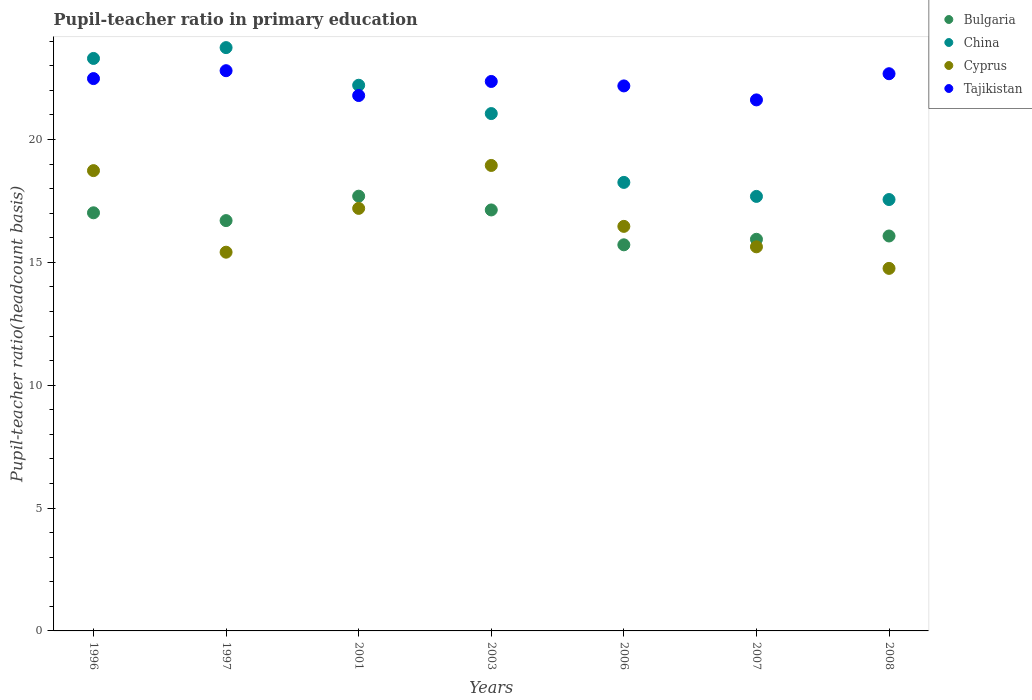Is the number of dotlines equal to the number of legend labels?
Your response must be concise. Yes. What is the pupil-teacher ratio in primary education in Bulgaria in 1996?
Keep it short and to the point. 17.01. Across all years, what is the maximum pupil-teacher ratio in primary education in Cyprus?
Provide a succinct answer. 18.94. Across all years, what is the minimum pupil-teacher ratio in primary education in Bulgaria?
Your answer should be compact. 15.71. In which year was the pupil-teacher ratio in primary education in Bulgaria minimum?
Your answer should be very brief. 2006. What is the total pupil-teacher ratio in primary education in Tajikistan in the graph?
Your response must be concise. 155.88. What is the difference between the pupil-teacher ratio in primary education in Tajikistan in 1996 and that in 2001?
Offer a terse response. 0.69. What is the difference between the pupil-teacher ratio in primary education in China in 2006 and the pupil-teacher ratio in primary education in Cyprus in 2008?
Give a very brief answer. 3.5. What is the average pupil-teacher ratio in primary education in China per year?
Ensure brevity in your answer.  20.54. In the year 2006, what is the difference between the pupil-teacher ratio in primary education in Cyprus and pupil-teacher ratio in primary education in China?
Offer a terse response. -1.79. What is the ratio of the pupil-teacher ratio in primary education in China in 1996 to that in 2003?
Provide a succinct answer. 1.11. Is the pupil-teacher ratio in primary education in China in 2007 less than that in 2008?
Offer a very short reply. No. Is the difference between the pupil-teacher ratio in primary education in Cyprus in 2006 and 2007 greater than the difference between the pupil-teacher ratio in primary education in China in 2006 and 2007?
Provide a short and direct response. Yes. What is the difference between the highest and the second highest pupil-teacher ratio in primary education in China?
Make the answer very short. 0.44. What is the difference between the highest and the lowest pupil-teacher ratio in primary education in Bulgaria?
Give a very brief answer. 1.98. In how many years, is the pupil-teacher ratio in primary education in Bulgaria greater than the average pupil-teacher ratio in primary education in Bulgaria taken over all years?
Provide a short and direct response. 4. Is the sum of the pupil-teacher ratio in primary education in Cyprus in 1996 and 2008 greater than the maximum pupil-teacher ratio in primary education in Tajikistan across all years?
Keep it short and to the point. Yes. Is it the case that in every year, the sum of the pupil-teacher ratio in primary education in Bulgaria and pupil-teacher ratio in primary education in Cyprus  is greater than the sum of pupil-teacher ratio in primary education in China and pupil-teacher ratio in primary education in Tajikistan?
Provide a succinct answer. No. Does the pupil-teacher ratio in primary education in Bulgaria monotonically increase over the years?
Offer a very short reply. No. Is the pupil-teacher ratio in primary education in Bulgaria strictly greater than the pupil-teacher ratio in primary education in China over the years?
Keep it short and to the point. No. Is the pupil-teacher ratio in primary education in China strictly less than the pupil-teacher ratio in primary education in Tajikistan over the years?
Provide a short and direct response. No. What is the difference between two consecutive major ticks on the Y-axis?
Offer a terse response. 5. Does the graph contain grids?
Your answer should be very brief. No. Where does the legend appear in the graph?
Your answer should be compact. Top right. How many legend labels are there?
Offer a terse response. 4. How are the legend labels stacked?
Your answer should be compact. Vertical. What is the title of the graph?
Give a very brief answer. Pupil-teacher ratio in primary education. What is the label or title of the X-axis?
Offer a very short reply. Years. What is the label or title of the Y-axis?
Make the answer very short. Pupil-teacher ratio(headcount basis). What is the Pupil-teacher ratio(headcount basis) in Bulgaria in 1996?
Your answer should be very brief. 17.01. What is the Pupil-teacher ratio(headcount basis) in China in 1996?
Your answer should be very brief. 23.3. What is the Pupil-teacher ratio(headcount basis) of Cyprus in 1996?
Your answer should be very brief. 18.73. What is the Pupil-teacher ratio(headcount basis) of Tajikistan in 1996?
Your response must be concise. 22.48. What is the Pupil-teacher ratio(headcount basis) in Bulgaria in 1997?
Provide a succinct answer. 16.7. What is the Pupil-teacher ratio(headcount basis) of China in 1997?
Offer a terse response. 23.74. What is the Pupil-teacher ratio(headcount basis) of Cyprus in 1997?
Your response must be concise. 15.41. What is the Pupil-teacher ratio(headcount basis) in Tajikistan in 1997?
Your response must be concise. 22.8. What is the Pupil-teacher ratio(headcount basis) of Bulgaria in 2001?
Your answer should be very brief. 17.69. What is the Pupil-teacher ratio(headcount basis) in China in 2001?
Your answer should be compact. 22.21. What is the Pupil-teacher ratio(headcount basis) of Cyprus in 2001?
Your answer should be compact. 17.19. What is the Pupil-teacher ratio(headcount basis) in Tajikistan in 2001?
Your answer should be compact. 21.79. What is the Pupil-teacher ratio(headcount basis) in Bulgaria in 2003?
Make the answer very short. 17.13. What is the Pupil-teacher ratio(headcount basis) of China in 2003?
Keep it short and to the point. 21.05. What is the Pupil-teacher ratio(headcount basis) in Cyprus in 2003?
Give a very brief answer. 18.94. What is the Pupil-teacher ratio(headcount basis) in Tajikistan in 2003?
Give a very brief answer. 22.36. What is the Pupil-teacher ratio(headcount basis) of Bulgaria in 2006?
Provide a short and direct response. 15.71. What is the Pupil-teacher ratio(headcount basis) in China in 2006?
Offer a very short reply. 18.25. What is the Pupil-teacher ratio(headcount basis) in Cyprus in 2006?
Ensure brevity in your answer.  16.46. What is the Pupil-teacher ratio(headcount basis) in Tajikistan in 2006?
Provide a short and direct response. 22.18. What is the Pupil-teacher ratio(headcount basis) in Bulgaria in 2007?
Make the answer very short. 15.94. What is the Pupil-teacher ratio(headcount basis) in China in 2007?
Your answer should be compact. 17.68. What is the Pupil-teacher ratio(headcount basis) of Cyprus in 2007?
Keep it short and to the point. 15.63. What is the Pupil-teacher ratio(headcount basis) in Tajikistan in 2007?
Offer a terse response. 21.61. What is the Pupil-teacher ratio(headcount basis) in Bulgaria in 2008?
Provide a succinct answer. 16.07. What is the Pupil-teacher ratio(headcount basis) in China in 2008?
Give a very brief answer. 17.55. What is the Pupil-teacher ratio(headcount basis) of Cyprus in 2008?
Your response must be concise. 14.75. What is the Pupil-teacher ratio(headcount basis) in Tajikistan in 2008?
Offer a terse response. 22.67. Across all years, what is the maximum Pupil-teacher ratio(headcount basis) in Bulgaria?
Your response must be concise. 17.69. Across all years, what is the maximum Pupil-teacher ratio(headcount basis) of China?
Offer a terse response. 23.74. Across all years, what is the maximum Pupil-teacher ratio(headcount basis) of Cyprus?
Provide a succinct answer. 18.94. Across all years, what is the maximum Pupil-teacher ratio(headcount basis) in Tajikistan?
Your answer should be very brief. 22.8. Across all years, what is the minimum Pupil-teacher ratio(headcount basis) in Bulgaria?
Ensure brevity in your answer.  15.71. Across all years, what is the minimum Pupil-teacher ratio(headcount basis) of China?
Make the answer very short. 17.55. Across all years, what is the minimum Pupil-teacher ratio(headcount basis) of Cyprus?
Ensure brevity in your answer.  14.75. Across all years, what is the minimum Pupil-teacher ratio(headcount basis) in Tajikistan?
Ensure brevity in your answer.  21.61. What is the total Pupil-teacher ratio(headcount basis) in Bulgaria in the graph?
Provide a succinct answer. 116.25. What is the total Pupil-teacher ratio(headcount basis) of China in the graph?
Offer a terse response. 143.78. What is the total Pupil-teacher ratio(headcount basis) in Cyprus in the graph?
Ensure brevity in your answer.  117.13. What is the total Pupil-teacher ratio(headcount basis) of Tajikistan in the graph?
Keep it short and to the point. 155.88. What is the difference between the Pupil-teacher ratio(headcount basis) of Bulgaria in 1996 and that in 1997?
Make the answer very short. 0.32. What is the difference between the Pupil-teacher ratio(headcount basis) in China in 1996 and that in 1997?
Offer a terse response. -0.44. What is the difference between the Pupil-teacher ratio(headcount basis) in Cyprus in 1996 and that in 1997?
Give a very brief answer. 3.32. What is the difference between the Pupil-teacher ratio(headcount basis) in Tajikistan in 1996 and that in 1997?
Your response must be concise. -0.32. What is the difference between the Pupil-teacher ratio(headcount basis) of Bulgaria in 1996 and that in 2001?
Your answer should be very brief. -0.68. What is the difference between the Pupil-teacher ratio(headcount basis) in China in 1996 and that in 2001?
Make the answer very short. 1.09. What is the difference between the Pupil-teacher ratio(headcount basis) of Cyprus in 1996 and that in 2001?
Offer a very short reply. 1.54. What is the difference between the Pupil-teacher ratio(headcount basis) in Tajikistan in 1996 and that in 2001?
Offer a terse response. 0.69. What is the difference between the Pupil-teacher ratio(headcount basis) in Bulgaria in 1996 and that in 2003?
Give a very brief answer. -0.12. What is the difference between the Pupil-teacher ratio(headcount basis) in China in 1996 and that in 2003?
Your response must be concise. 2.24. What is the difference between the Pupil-teacher ratio(headcount basis) in Cyprus in 1996 and that in 2003?
Provide a succinct answer. -0.21. What is the difference between the Pupil-teacher ratio(headcount basis) in Tajikistan in 1996 and that in 2003?
Keep it short and to the point. 0.12. What is the difference between the Pupil-teacher ratio(headcount basis) in Bulgaria in 1996 and that in 2006?
Provide a short and direct response. 1.3. What is the difference between the Pupil-teacher ratio(headcount basis) in China in 1996 and that in 2006?
Offer a very short reply. 5.04. What is the difference between the Pupil-teacher ratio(headcount basis) of Cyprus in 1996 and that in 2006?
Keep it short and to the point. 2.27. What is the difference between the Pupil-teacher ratio(headcount basis) of Tajikistan in 1996 and that in 2006?
Give a very brief answer. 0.3. What is the difference between the Pupil-teacher ratio(headcount basis) of Bulgaria in 1996 and that in 2007?
Keep it short and to the point. 1.08. What is the difference between the Pupil-teacher ratio(headcount basis) of China in 1996 and that in 2007?
Offer a terse response. 5.61. What is the difference between the Pupil-teacher ratio(headcount basis) of Cyprus in 1996 and that in 2007?
Provide a short and direct response. 3.1. What is the difference between the Pupil-teacher ratio(headcount basis) in Tajikistan in 1996 and that in 2007?
Keep it short and to the point. 0.87. What is the difference between the Pupil-teacher ratio(headcount basis) in Bulgaria in 1996 and that in 2008?
Provide a short and direct response. 0.94. What is the difference between the Pupil-teacher ratio(headcount basis) of China in 1996 and that in 2008?
Your response must be concise. 5.74. What is the difference between the Pupil-teacher ratio(headcount basis) of Cyprus in 1996 and that in 2008?
Offer a terse response. 3.98. What is the difference between the Pupil-teacher ratio(headcount basis) in Tajikistan in 1996 and that in 2008?
Offer a terse response. -0.2. What is the difference between the Pupil-teacher ratio(headcount basis) of Bulgaria in 1997 and that in 2001?
Offer a terse response. -0.99. What is the difference between the Pupil-teacher ratio(headcount basis) of China in 1997 and that in 2001?
Offer a terse response. 1.53. What is the difference between the Pupil-teacher ratio(headcount basis) in Cyprus in 1997 and that in 2001?
Your answer should be compact. -1.78. What is the difference between the Pupil-teacher ratio(headcount basis) of Tajikistan in 1997 and that in 2001?
Make the answer very short. 1.01. What is the difference between the Pupil-teacher ratio(headcount basis) of Bulgaria in 1997 and that in 2003?
Your answer should be very brief. -0.43. What is the difference between the Pupil-teacher ratio(headcount basis) of China in 1997 and that in 2003?
Ensure brevity in your answer.  2.68. What is the difference between the Pupil-teacher ratio(headcount basis) of Cyprus in 1997 and that in 2003?
Offer a terse response. -3.53. What is the difference between the Pupil-teacher ratio(headcount basis) in Tajikistan in 1997 and that in 2003?
Your answer should be very brief. 0.44. What is the difference between the Pupil-teacher ratio(headcount basis) of Bulgaria in 1997 and that in 2006?
Give a very brief answer. 0.99. What is the difference between the Pupil-teacher ratio(headcount basis) in China in 1997 and that in 2006?
Your response must be concise. 5.49. What is the difference between the Pupil-teacher ratio(headcount basis) of Cyprus in 1997 and that in 2006?
Give a very brief answer. -1.05. What is the difference between the Pupil-teacher ratio(headcount basis) of Tajikistan in 1997 and that in 2006?
Provide a short and direct response. 0.62. What is the difference between the Pupil-teacher ratio(headcount basis) of Bulgaria in 1997 and that in 2007?
Offer a very short reply. 0.76. What is the difference between the Pupil-teacher ratio(headcount basis) in China in 1997 and that in 2007?
Your answer should be very brief. 6.05. What is the difference between the Pupil-teacher ratio(headcount basis) of Cyprus in 1997 and that in 2007?
Ensure brevity in your answer.  -0.22. What is the difference between the Pupil-teacher ratio(headcount basis) of Tajikistan in 1997 and that in 2007?
Your response must be concise. 1.19. What is the difference between the Pupil-teacher ratio(headcount basis) of Bulgaria in 1997 and that in 2008?
Ensure brevity in your answer.  0.63. What is the difference between the Pupil-teacher ratio(headcount basis) in China in 1997 and that in 2008?
Offer a very short reply. 6.18. What is the difference between the Pupil-teacher ratio(headcount basis) in Cyprus in 1997 and that in 2008?
Your answer should be compact. 0.66. What is the difference between the Pupil-teacher ratio(headcount basis) in Tajikistan in 1997 and that in 2008?
Offer a terse response. 0.12. What is the difference between the Pupil-teacher ratio(headcount basis) of Bulgaria in 2001 and that in 2003?
Your answer should be compact. 0.56. What is the difference between the Pupil-teacher ratio(headcount basis) in China in 2001 and that in 2003?
Give a very brief answer. 1.15. What is the difference between the Pupil-teacher ratio(headcount basis) of Cyprus in 2001 and that in 2003?
Give a very brief answer. -1.75. What is the difference between the Pupil-teacher ratio(headcount basis) of Tajikistan in 2001 and that in 2003?
Your answer should be very brief. -0.57. What is the difference between the Pupil-teacher ratio(headcount basis) in Bulgaria in 2001 and that in 2006?
Provide a short and direct response. 1.98. What is the difference between the Pupil-teacher ratio(headcount basis) of China in 2001 and that in 2006?
Offer a very short reply. 3.95. What is the difference between the Pupil-teacher ratio(headcount basis) of Cyprus in 2001 and that in 2006?
Your answer should be compact. 0.73. What is the difference between the Pupil-teacher ratio(headcount basis) of Tajikistan in 2001 and that in 2006?
Provide a succinct answer. -0.39. What is the difference between the Pupil-teacher ratio(headcount basis) of Bulgaria in 2001 and that in 2007?
Ensure brevity in your answer.  1.75. What is the difference between the Pupil-teacher ratio(headcount basis) in China in 2001 and that in 2007?
Provide a short and direct response. 4.52. What is the difference between the Pupil-teacher ratio(headcount basis) of Cyprus in 2001 and that in 2007?
Your answer should be compact. 1.56. What is the difference between the Pupil-teacher ratio(headcount basis) of Tajikistan in 2001 and that in 2007?
Offer a very short reply. 0.18. What is the difference between the Pupil-teacher ratio(headcount basis) of Bulgaria in 2001 and that in 2008?
Your answer should be very brief. 1.62. What is the difference between the Pupil-teacher ratio(headcount basis) of China in 2001 and that in 2008?
Keep it short and to the point. 4.65. What is the difference between the Pupil-teacher ratio(headcount basis) in Cyprus in 2001 and that in 2008?
Keep it short and to the point. 2.44. What is the difference between the Pupil-teacher ratio(headcount basis) of Tajikistan in 2001 and that in 2008?
Make the answer very short. -0.89. What is the difference between the Pupil-teacher ratio(headcount basis) in Bulgaria in 2003 and that in 2006?
Your answer should be very brief. 1.42. What is the difference between the Pupil-teacher ratio(headcount basis) of China in 2003 and that in 2006?
Your answer should be compact. 2.8. What is the difference between the Pupil-teacher ratio(headcount basis) in Cyprus in 2003 and that in 2006?
Provide a succinct answer. 2.48. What is the difference between the Pupil-teacher ratio(headcount basis) of Tajikistan in 2003 and that in 2006?
Ensure brevity in your answer.  0.18. What is the difference between the Pupil-teacher ratio(headcount basis) of Bulgaria in 2003 and that in 2007?
Offer a very short reply. 1.19. What is the difference between the Pupil-teacher ratio(headcount basis) of China in 2003 and that in 2007?
Provide a succinct answer. 3.37. What is the difference between the Pupil-teacher ratio(headcount basis) of Cyprus in 2003 and that in 2007?
Ensure brevity in your answer.  3.31. What is the difference between the Pupil-teacher ratio(headcount basis) in Tajikistan in 2003 and that in 2007?
Provide a succinct answer. 0.75. What is the difference between the Pupil-teacher ratio(headcount basis) of Bulgaria in 2003 and that in 2008?
Provide a succinct answer. 1.06. What is the difference between the Pupil-teacher ratio(headcount basis) of China in 2003 and that in 2008?
Offer a terse response. 3.5. What is the difference between the Pupil-teacher ratio(headcount basis) in Cyprus in 2003 and that in 2008?
Offer a terse response. 4.19. What is the difference between the Pupil-teacher ratio(headcount basis) of Tajikistan in 2003 and that in 2008?
Your response must be concise. -0.31. What is the difference between the Pupil-teacher ratio(headcount basis) in Bulgaria in 2006 and that in 2007?
Your answer should be compact. -0.23. What is the difference between the Pupil-teacher ratio(headcount basis) in China in 2006 and that in 2007?
Offer a terse response. 0.57. What is the difference between the Pupil-teacher ratio(headcount basis) of Cyprus in 2006 and that in 2007?
Offer a very short reply. 0.83. What is the difference between the Pupil-teacher ratio(headcount basis) in Tajikistan in 2006 and that in 2007?
Give a very brief answer. 0.57. What is the difference between the Pupil-teacher ratio(headcount basis) in Bulgaria in 2006 and that in 2008?
Offer a terse response. -0.36. What is the difference between the Pupil-teacher ratio(headcount basis) in China in 2006 and that in 2008?
Your answer should be very brief. 0.7. What is the difference between the Pupil-teacher ratio(headcount basis) in Cyprus in 2006 and that in 2008?
Make the answer very short. 1.71. What is the difference between the Pupil-teacher ratio(headcount basis) in Tajikistan in 2006 and that in 2008?
Your answer should be compact. -0.5. What is the difference between the Pupil-teacher ratio(headcount basis) of Bulgaria in 2007 and that in 2008?
Your answer should be very brief. -0.13. What is the difference between the Pupil-teacher ratio(headcount basis) in China in 2007 and that in 2008?
Your answer should be compact. 0.13. What is the difference between the Pupil-teacher ratio(headcount basis) of Cyprus in 2007 and that in 2008?
Keep it short and to the point. 0.88. What is the difference between the Pupil-teacher ratio(headcount basis) of Tajikistan in 2007 and that in 2008?
Your answer should be compact. -1.06. What is the difference between the Pupil-teacher ratio(headcount basis) in Bulgaria in 1996 and the Pupil-teacher ratio(headcount basis) in China in 1997?
Offer a terse response. -6.72. What is the difference between the Pupil-teacher ratio(headcount basis) in Bulgaria in 1996 and the Pupil-teacher ratio(headcount basis) in Cyprus in 1997?
Give a very brief answer. 1.6. What is the difference between the Pupil-teacher ratio(headcount basis) in Bulgaria in 1996 and the Pupil-teacher ratio(headcount basis) in Tajikistan in 1997?
Your answer should be very brief. -5.78. What is the difference between the Pupil-teacher ratio(headcount basis) in China in 1996 and the Pupil-teacher ratio(headcount basis) in Cyprus in 1997?
Provide a succinct answer. 7.88. What is the difference between the Pupil-teacher ratio(headcount basis) in China in 1996 and the Pupil-teacher ratio(headcount basis) in Tajikistan in 1997?
Keep it short and to the point. 0.5. What is the difference between the Pupil-teacher ratio(headcount basis) of Cyprus in 1996 and the Pupil-teacher ratio(headcount basis) of Tajikistan in 1997?
Your answer should be compact. -4.07. What is the difference between the Pupil-teacher ratio(headcount basis) in Bulgaria in 1996 and the Pupil-teacher ratio(headcount basis) in China in 2001?
Provide a short and direct response. -5.19. What is the difference between the Pupil-teacher ratio(headcount basis) of Bulgaria in 1996 and the Pupil-teacher ratio(headcount basis) of Cyprus in 2001?
Provide a short and direct response. -0.18. What is the difference between the Pupil-teacher ratio(headcount basis) in Bulgaria in 1996 and the Pupil-teacher ratio(headcount basis) in Tajikistan in 2001?
Keep it short and to the point. -4.77. What is the difference between the Pupil-teacher ratio(headcount basis) in China in 1996 and the Pupil-teacher ratio(headcount basis) in Cyprus in 2001?
Your response must be concise. 6.1. What is the difference between the Pupil-teacher ratio(headcount basis) in China in 1996 and the Pupil-teacher ratio(headcount basis) in Tajikistan in 2001?
Ensure brevity in your answer.  1.51. What is the difference between the Pupil-teacher ratio(headcount basis) in Cyprus in 1996 and the Pupil-teacher ratio(headcount basis) in Tajikistan in 2001?
Your response must be concise. -3.06. What is the difference between the Pupil-teacher ratio(headcount basis) of Bulgaria in 1996 and the Pupil-teacher ratio(headcount basis) of China in 2003?
Ensure brevity in your answer.  -4.04. What is the difference between the Pupil-teacher ratio(headcount basis) in Bulgaria in 1996 and the Pupil-teacher ratio(headcount basis) in Cyprus in 2003?
Make the answer very short. -1.93. What is the difference between the Pupil-teacher ratio(headcount basis) of Bulgaria in 1996 and the Pupil-teacher ratio(headcount basis) of Tajikistan in 2003?
Give a very brief answer. -5.34. What is the difference between the Pupil-teacher ratio(headcount basis) of China in 1996 and the Pupil-teacher ratio(headcount basis) of Cyprus in 2003?
Offer a terse response. 4.35. What is the difference between the Pupil-teacher ratio(headcount basis) in China in 1996 and the Pupil-teacher ratio(headcount basis) in Tajikistan in 2003?
Give a very brief answer. 0.94. What is the difference between the Pupil-teacher ratio(headcount basis) in Cyprus in 1996 and the Pupil-teacher ratio(headcount basis) in Tajikistan in 2003?
Offer a terse response. -3.63. What is the difference between the Pupil-teacher ratio(headcount basis) of Bulgaria in 1996 and the Pupil-teacher ratio(headcount basis) of China in 2006?
Your answer should be very brief. -1.24. What is the difference between the Pupil-teacher ratio(headcount basis) of Bulgaria in 1996 and the Pupil-teacher ratio(headcount basis) of Cyprus in 2006?
Your answer should be very brief. 0.55. What is the difference between the Pupil-teacher ratio(headcount basis) of Bulgaria in 1996 and the Pupil-teacher ratio(headcount basis) of Tajikistan in 2006?
Offer a terse response. -5.16. What is the difference between the Pupil-teacher ratio(headcount basis) in China in 1996 and the Pupil-teacher ratio(headcount basis) in Cyprus in 2006?
Keep it short and to the point. 6.83. What is the difference between the Pupil-teacher ratio(headcount basis) of China in 1996 and the Pupil-teacher ratio(headcount basis) of Tajikistan in 2006?
Offer a terse response. 1.12. What is the difference between the Pupil-teacher ratio(headcount basis) in Cyprus in 1996 and the Pupil-teacher ratio(headcount basis) in Tajikistan in 2006?
Provide a succinct answer. -3.45. What is the difference between the Pupil-teacher ratio(headcount basis) of Bulgaria in 1996 and the Pupil-teacher ratio(headcount basis) of China in 2007?
Keep it short and to the point. -0.67. What is the difference between the Pupil-teacher ratio(headcount basis) in Bulgaria in 1996 and the Pupil-teacher ratio(headcount basis) in Cyprus in 2007?
Your answer should be very brief. 1.38. What is the difference between the Pupil-teacher ratio(headcount basis) in Bulgaria in 1996 and the Pupil-teacher ratio(headcount basis) in Tajikistan in 2007?
Your answer should be very brief. -4.59. What is the difference between the Pupil-teacher ratio(headcount basis) of China in 1996 and the Pupil-teacher ratio(headcount basis) of Cyprus in 2007?
Your answer should be compact. 7.67. What is the difference between the Pupil-teacher ratio(headcount basis) in China in 1996 and the Pupil-teacher ratio(headcount basis) in Tajikistan in 2007?
Provide a succinct answer. 1.69. What is the difference between the Pupil-teacher ratio(headcount basis) of Cyprus in 1996 and the Pupil-teacher ratio(headcount basis) of Tajikistan in 2007?
Make the answer very short. -2.88. What is the difference between the Pupil-teacher ratio(headcount basis) in Bulgaria in 1996 and the Pupil-teacher ratio(headcount basis) in China in 2008?
Give a very brief answer. -0.54. What is the difference between the Pupil-teacher ratio(headcount basis) of Bulgaria in 1996 and the Pupil-teacher ratio(headcount basis) of Cyprus in 2008?
Give a very brief answer. 2.26. What is the difference between the Pupil-teacher ratio(headcount basis) of Bulgaria in 1996 and the Pupil-teacher ratio(headcount basis) of Tajikistan in 2008?
Ensure brevity in your answer.  -5.66. What is the difference between the Pupil-teacher ratio(headcount basis) in China in 1996 and the Pupil-teacher ratio(headcount basis) in Cyprus in 2008?
Provide a succinct answer. 8.54. What is the difference between the Pupil-teacher ratio(headcount basis) in China in 1996 and the Pupil-teacher ratio(headcount basis) in Tajikistan in 2008?
Your answer should be very brief. 0.62. What is the difference between the Pupil-teacher ratio(headcount basis) in Cyprus in 1996 and the Pupil-teacher ratio(headcount basis) in Tajikistan in 2008?
Provide a succinct answer. -3.94. What is the difference between the Pupil-teacher ratio(headcount basis) in Bulgaria in 1997 and the Pupil-teacher ratio(headcount basis) in China in 2001?
Make the answer very short. -5.51. What is the difference between the Pupil-teacher ratio(headcount basis) of Bulgaria in 1997 and the Pupil-teacher ratio(headcount basis) of Cyprus in 2001?
Provide a succinct answer. -0.5. What is the difference between the Pupil-teacher ratio(headcount basis) of Bulgaria in 1997 and the Pupil-teacher ratio(headcount basis) of Tajikistan in 2001?
Give a very brief answer. -5.09. What is the difference between the Pupil-teacher ratio(headcount basis) in China in 1997 and the Pupil-teacher ratio(headcount basis) in Cyprus in 2001?
Provide a short and direct response. 6.54. What is the difference between the Pupil-teacher ratio(headcount basis) in China in 1997 and the Pupil-teacher ratio(headcount basis) in Tajikistan in 2001?
Give a very brief answer. 1.95. What is the difference between the Pupil-teacher ratio(headcount basis) of Cyprus in 1997 and the Pupil-teacher ratio(headcount basis) of Tajikistan in 2001?
Offer a terse response. -6.37. What is the difference between the Pupil-teacher ratio(headcount basis) of Bulgaria in 1997 and the Pupil-teacher ratio(headcount basis) of China in 2003?
Offer a terse response. -4.36. What is the difference between the Pupil-teacher ratio(headcount basis) in Bulgaria in 1997 and the Pupil-teacher ratio(headcount basis) in Cyprus in 2003?
Provide a short and direct response. -2.24. What is the difference between the Pupil-teacher ratio(headcount basis) in Bulgaria in 1997 and the Pupil-teacher ratio(headcount basis) in Tajikistan in 2003?
Keep it short and to the point. -5.66. What is the difference between the Pupil-teacher ratio(headcount basis) of China in 1997 and the Pupil-teacher ratio(headcount basis) of Cyprus in 2003?
Your answer should be very brief. 4.8. What is the difference between the Pupil-teacher ratio(headcount basis) of China in 1997 and the Pupil-teacher ratio(headcount basis) of Tajikistan in 2003?
Your answer should be very brief. 1.38. What is the difference between the Pupil-teacher ratio(headcount basis) of Cyprus in 1997 and the Pupil-teacher ratio(headcount basis) of Tajikistan in 2003?
Your answer should be compact. -6.95. What is the difference between the Pupil-teacher ratio(headcount basis) in Bulgaria in 1997 and the Pupil-teacher ratio(headcount basis) in China in 2006?
Your answer should be compact. -1.55. What is the difference between the Pupil-teacher ratio(headcount basis) of Bulgaria in 1997 and the Pupil-teacher ratio(headcount basis) of Cyprus in 2006?
Offer a terse response. 0.23. What is the difference between the Pupil-teacher ratio(headcount basis) in Bulgaria in 1997 and the Pupil-teacher ratio(headcount basis) in Tajikistan in 2006?
Give a very brief answer. -5.48. What is the difference between the Pupil-teacher ratio(headcount basis) of China in 1997 and the Pupil-teacher ratio(headcount basis) of Cyprus in 2006?
Keep it short and to the point. 7.27. What is the difference between the Pupil-teacher ratio(headcount basis) of China in 1997 and the Pupil-teacher ratio(headcount basis) of Tajikistan in 2006?
Your answer should be compact. 1.56. What is the difference between the Pupil-teacher ratio(headcount basis) of Cyprus in 1997 and the Pupil-teacher ratio(headcount basis) of Tajikistan in 2006?
Ensure brevity in your answer.  -6.77. What is the difference between the Pupil-teacher ratio(headcount basis) in Bulgaria in 1997 and the Pupil-teacher ratio(headcount basis) in China in 2007?
Provide a short and direct response. -0.98. What is the difference between the Pupil-teacher ratio(headcount basis) of Bulgaria in 1997 and the Pupil-teacher ratio(headcount basis) of Cyprus in 2007?
Your response must be concise. 1.07. What is the difference between the Pupil-teacher ratio(headcount basis) in Bulgaria in 1997 and the Pupil-teacher ratio(headcount basis) in Tajikistan in 2007?
Keep it short and to the point. -4.91. What is the difference between the Pupil-teacher ratio(headcount basis) in China in 1997 and the Pupil-teacher ratio(headcount basis) in Cyprus in 2007?
Your answer should be very brief. 8.11. What is the difference between the Pupil-teacher ratio(headcount basis) of China in 1997 and the Pupil-teacher ratio(headcount basis) of Tajikistan in 2007?
Give a very brief answer. 2.13. What is the difference between the Pupil-teacher ratio(headcount basis) of Cyprus in 1997 and the Pupil-teacher ratio(headcount basis) of Tajikistan in 2007?
Your answer should be compact. -6.2. What is the difference between the Pupil-teacher ratio(headcount basis) of Bulgaria in 1997 and the Pupil-teacher ratio(headcount basis) of China in 2008?
Offer a very short reply. -0.86. What is the difference between the Pupil-teacher ratio(headcount basis) in Bulgaria in 1997 and the Pupil-teacher ratio(headcount basis) in Cyprus in 2008?
Your answer should be compact. 1.94. What is the difference between the Pupil-teacher ratio(headcount basis) in Bulgaria in 1997 and the Pupil-teacher ratio(headcount basis) in Tajikistan in 2008?
Provide a short and direct response. -5.98. What is the difference between the Pupil-teacher ratio(headcount basis) of China in 1997 and the Pupil-teacher ratio(headcount basis) of Cyprus in 2008?
Provide a short and direct response. 8.98. What is the difference between the Pupil-teacher ratio(headcount basis) of China in 1997 and the Pupil-teacher ratio(headcount basis) of Tajikistan in 2008?
Ensure brevity in your answer.  1.06. What is the difference between the Pupil-teacher ratio(headcount basis) of Cyprus in 1997 and the Pupil-teacher ratio(headcount basis) of Tajikistan in 2008?
Give a very brief answer. -7.26. What is the difference between the Pupil-teacher ratio(headcount basis) of Bulgaria in 2001 and the Pupil-teacher ratio(headcount basis) of China in 2003?
Keep it short and to the point. -3.36. What is the difference between the Pupil-teacher ratio(headcount basis) of Bulgaria in 2001 and the Pupil-teacher ratio(headcount basis) of Cyprus in 2003?
Provide a succinct answer. -1.25. What is the difference between the Pupil-teacher ratio(headcount basis) in Bulgaria in 2001 and the Pupil-teacher ratio(headcount basis) in Tajikistan in 2003?
Provide a succinct answer. -4.67. What is the difference between the Pupil-teacher ratio(headcount basis) in China in 2001 and the Pupil-teacher ratio(headcount basis) in Cyprus in 2003?
Ensure brevity in your answer.  3.26. What is the difference between the Pupil-teacher ratio(headcount basis) of China in 2001 and the Pupil-teacher ratio(headcount basis) of Tajikistan in 2003?
Offer a terse response. -0.15. What is the difference between the Pupil-teacher ratio(headcount basis) of Cyprus in 2001 and the Pupil-teacher ratio(headcount basis) of Tajikistan in 2003?
Your response must be concise. -5.16. What is the difference between the Pupil-teacher ratio(headcount basis) in Bulgaria in 2001 and the Pupil-teacher ratio(headcount basis) in China in 2006?
Keep it short and to the point. -0.56. What is the difference between the Pupil-teacher ratio(headcount basis) in Bulgaria in 2001 and the Pupil-teacher ratio(headcount basis) in Cyprus in 2006?
Your answer should be very brief. 1.23. What is the difference between the Pupil-teacher ratio(headcount basis) in Bulgaria in 2001 and the Pupil-teacher ratio(headcount basis) in Tajikistan in 2006?
Your response must be concise. -4.49. What is the difference between the Pupil-teacher ratio(headcount basis) in China in 2001 and the Pupil-teacher ratio(headcount basis) in Cyprus in 2006?
Offer a terse response. 5.74. What is the difference between the Pupil-teacher ratio(headcount basis) of China in 2001 and the Pupil-teacher ratio(headcount basis) of Tajikistan in 2006?
Offer a terse response. 0.03. What is the difference between the Pupil-teacher ratio(headcount basis) in Cyprus in 2001 and the Pupil-teacher ratio(headcount basis) in Tajikistan in 2006?
Ensure brevity in your answer.  -4.98. What is the difference between the Pupil-teacher ratio(headcount basis) in Bulgaria in 2001 and the Pupil-teacher ratio(headcount basis) in China in 2007?
Provide a short and direct response. 0.01. What is the difference between the Pupil-teacher ratio(headcount basis) of Bulgaria in 2001 and the Pupil-teacher ratio(headcount basis) of Cyprus in 2007?
Provide a succinct answer. 2.06. What is the difference between the Pupil-teacher ratio(headcount basis) of Bulgaria in 2001 and the Pupil-teacher ratio(headcount basis) of Tajikistan in 2007?
Provide a succinct answer. -3.92. What is the difference between the Pupil-teacher ratio(headcount basis) of China in 2001 and the Pupil-teacher ratio(headcount basis) of Cyprus in 2007?
Ensure brevity in your answer.  6.58. What is the difference between the Pupil-teacher ratio(headcount basis) of China in 2001 and the Pupil-teacher ratio(headcount basis) of Tajikistan in 2007?
Your answer should be very brief. 0.6. What is the difference between the Pupil-teacher ratio(headcount basis) in Cyprus in 2001 and the Pupil-teacher ratio(headcount basis) in Tajikistan in 2007?
Give a very brief answer. -4.41. What is the difference between the Pupil-teacher ratio(headcount basis) in Bulgaria in 2001 and the Pupil-teacher ratio(headcount basis) in China in 2008?
Offer a very short reply. 0.14. What is the difference between the Pupil-teacher ratio(headcount basis) of Bulgaria in 2001 and the Pupil-teacher ratio(headcount basis) of Cyprus in 2008?
Give a very brief answer. 2.94. What is the difference between the Pupil-teacher ratio(headcount basis) in Bulgaria in 2001 and the Pupil-teacher ratio(headcount basis) in Tajikistan in 2008?
Provide a succinct answer. -4.98. What is the difference between the Pupil-teacher ratio(headcount basis) in China in 2001 and the Pupil-teacher ratio(headcount basis) in Cyprus in 2008?
Give a very brief answer. 7.45. What is the difference between the Pupil-teacher ratio(headcount basis) in China in 2001 and the Pupil-teacher ratio(headcount basis) in Tajikistan in 2008?
Keep it short and to the point. -0.47. What is the difference between the Pupil-teacher ratio(headcount basis) in Cyprus in 2001 and the Pupil-teacher ratio(headcount basis) in Tajikistan in 2008?
Your answer should be very brief. -5.48. What is the difference between the Pupil-teacher ratio(headcount basis) of Bulgaria in 2003 and the Pupil-teacher ratio(headcount basis) of China in 2006?
Offer a terse response. -1.12. What is the difference between the Pupil-teacher ratio(headcount basis) of Bulgaria in 2003 and the Pupil-teacher ratio(headcount basis) of Cyprus in 2006?
Ensure brevity in your answer.  0.67. What is the difference between the Pupil-teacher ratio(headcount basis) in Bulgaria in 2003 and the Pupil-teacher ratio(headcount basis) in Tajikistan in 2006?
Make the answer very short. -5.05. What is the difference between the Pupil-teacher ratio(headcount basis) of China in 2003 and the Pupil-teacher ratio(headcount basis) of Cyprus in 2006?
Ensure brevity in your answer.  4.59. What is the difference between the Pupil-teacher ratio(headcount basis) of China in 2003 and the Pupil-teacher ratio(headcount basis) of Tajikistan in 2006?
Give a very brief answer. -1.13. What is the difference between the Pupil-teacher ratio(headcount basis) in Cyprus in 2003 and the Pupil-teacher ratio(headcount basis) in Tajikistan in 2006?
Ensure brevity in your answer.  -3.24. What is the difference between the Pupil-teacher ratio(headcount basis) of Bulgaria in 2003 and the Pupil-teacher ratio(headcount basis) of China in 2007?
Your response must be concise. -0.55. What is the difference between the Pupil-teacher ratio(headcount basis) of Bulgaria in 2003 and the Pupil-teacher ratio(headcount basis) of Cyprus in 2007?
Make the answer very short. 1.5. What is the difference between the Pupil-teacher ratio(headcount basis) in Bulgaria in 2003 and the Pupil-teacher ratio(headcount basis) in Tajikistan in 2007?
Provide a succinct answer. -4.48. What is the difference between the Pupil-teacher ratio(headcount basis) of China in 2003 and the Pupil-teacher ratio(headcount basis) of Cyprus in 2007?
Ensure brevity in your answer.  5.42. What is the difference between the Pupil-teacher ratio(headcount basis) of China in 2003 and the Pupil-teacher ratio(headcount basis) of Tajikistan in 2007?
Offer a terse response. -0.56. What is the difference between the Pupil-teacher ratio(headcount basis) of Cyprus in 2003 and the Pupil-teacher ratio(headcount basis) of Tajikistan in 2007?
Provide a succinct answer. -2.67. What is the difference between the Pupil-teacher ratio(headcount basis) of Bulgaria in 2003 and the Pupil-teacher ratio(headcount basis) of China in 2008?
Your answer should be very brief. -0.42. What is the difference between the Pupil-teacher ratio(headcount basis) of Bulgaria in 2003 and the Pupil-teacher ratio(headcount basis) of Cyprus in 2008?
Ensure brevity in your answer.  2.38. What is the difference between the Pupil-teacher ratio(headcount basis) of Bulgaria in 2003 and the Pupil-teacher ratio(headcount basis) of Tajikistan in 2008?
Keep it short and to the point. -5.54. What is the difference between the Pupil-teacher ratio(headcount basis) in China in 2003 and the Pupil-teacher ratio(headcount basis) in Cyprus in 2008?
Keep it short and to the point. 6.3. What is the difference between the Pupil-teacher ratio(headcount basis) of China in 2003 and the Pupil-teacher ratio(headcount basis) of Tajikistan in 2008?
Ensure brevity in your answer.  -1.62. What is the difference between the Pupil-teacher ratio(headcount basis) of Cyprus in 2003 and the Pupil-teacher ratio(headcount basis) of Tajikistan in 2008?
Offer a terse response. -3.73. What is the difference between the Pupil-teacher ratio(headcount basis) in Bulgaria in 2006 and the Pupil-teacher ratio(headcount basis) in China in 2007?
Offer a terse response. -1.97. What is the difference between the Pupil-teacher ratio(headcount basis) in Bulgaria in 2006 and the Pupil-teacher ratio(headcount basis) in Cyprus in 2007?
Offer a very short reply. 0.08. What is the difference between the Pupil-teacher ratio(headcount basis) of Bulgaria in 2006 and the Pupil-teacher ratio(headcount basis) of Tajikistan in 2007?
Give a very brief answer. -5.9. What is the difference between the Pupil-teacher ratio(headcount basis) in China in 2006 and the Pupil-teacher ratio(headcount basis) in Cyprus in 2007?
Give a very brief answer. 2.62. What is the difference between the Pupil-teacher ratio(headcount basis) in China in 2006 and the Pupil-teacher ratio(headcount basis) in Tajikistan in 2007?
Offer a terse response. -3.36. What is the difference between the Pupil-teacher ratio(headcount basis) in Cyprus in 2006 and the Pupil-teacher ratio(headcount basis) in Tajikistan in 2007?
Offer a very short reply. -5.15. What is the difference between the Pupil-teacher ratio(headcount basis) in Bulgaria in 2006 and the Pupil-teacher ratio(headcount basis) in China in 2008?
Offer a very short reply. -1.84. What is the difference between the Pupil-teacher ratio(headcount basis) in Bulgaria in 2006 and the Pupil-teacher ratio(headcount basis) in Cyprus in 2008?
Your answer should be very brief. 0.96. What is the difference between the Pupil-teacher ratio(headcount basis) in Bulgaria in 2006 and the Pupil-teacher ratio(headcount basis) in Tajikistan in 2008?
Your answer should be very brief. -6.96. What is the difference between the Pupil-teacher ratio(headcount basis) of China in 2006 and the Pupil-teacher ratio(headcount basis) of Cyprus in 2008?
Offer a very short reply. 3.5. What is the difference between the Pupil-teacher ratio(headcount basis) of China in 2006 and the Pupil-teacher ratio(headcount basis) of Tajikistan in 2008?
Offer a very short reply. -4.42. What is the difference between the Pupil-teacher ratio(headcount basis) of Cyprus in 2006 and the Pupil-teacher ratio(headcount basis) of Tajikistan in 2008?
Offer a terse response. -6.21. What is the difference between the Pupil-teacher ratio(headcount basis) in Bulgaria in 2007 and the Pupil-teacher ratio(headcount basis) in China in 2008?
Provide a short and direct response. -1.62. What is the difference between the Pupil-teacher ratio(headcount basis) in Bulgaria in 2007 and the Pupil-teacher ratio(headcount basis) in Cyprus in 2008?
Offer a very short reply. 1.18. What is the difference between the Pupil-teacher ratio(headcount basis) in Bulgaria in 2007 and the Pupil-teacher ratio(headcount basis) in Tajikistan in 2008?
Offer a very short reply. -6.74. What is the difference between the Pupil-teacher ratio(headcount basis) in China in 2007 and the Pupil-teacher ratio(headcount basis) in Cyprus in 2008?
Provide a succinct answer. 2.93. What is the difference between the Pupil-teacher ratio(headcount basis) in China in 2007 and the Pupil-teacher ratio(headcount basis) in Tajikistan in 2008?
Make the answer very short. -4.99. What is the difference between the Pupil-teacher ratio(headcount basis) in Cyprus in 2007 and the Pupil-teacher ratio(headcount basis) in Tajikistan in 2008?
Your response must be concise. -7.04. What is the average Pupil-teacher ratio(headcount basis) of Bulgaria per year?
Provide a short and direct response. 16.61. What is the average Pupil-teacher ratio(headcount basis) of China per year?
Ensure brevity in your answer.  20.54. What is the average Pupil-teacher ratio(headcount basis) of Cyprus per year?
Keep it short and to the point. 16.73. What is the average Pupil-teacher ratio(headcount basis) of Tajikistan per year?
Provide a short and direct response. 22.27. In the year 1996, what is the difference between the Pupil-teacher ratio(headcount basis) of Bulgaria and Pupil-teacher ratio(headcount basis) of China?
Offer a very short reply. -6.28. In the year 1996, what is the difference between the Pupil-teacher ratio(headcount basis) of Bulgaria and Pupil-teacher ratio(headcount basis) of Cyprus?
Offer a very short reply. -1.72. In the year 1996, what is the difference between the Pupil-teacher ratio(headcount basis) in Bulgaria and Pupil-teacher ratio(headcount basis) in Tajikistan?
Your answer should be compact. -5.46. In the year 1996, what is the difference between the Pupil-teacher ratio(headcount basis) of China and Pupil-teacher ratio(headcount basis) of Cyprus?
Offer a very short reply. 4.57. In the year 1996, what is the difference between the Pupil-teacher ratio(headcount basis) of China and Pupil-teacher ratio(headcount basis) of Tajikistan?
Offer a terse response. 0.82. In the year 1996, what is the difference between the Pupil-teacher ratio(headcount basis) of Cyprus and Pupil-teacher ratio(headcount basis) of Tajikistan?
Keep it short and to the point. -3.75. In the year 1997, what is the difference between the Pupil-teacher ratio(headcount basis) of Bulgaria and Pupil-teacher ratio(headcount basis) of China?
Your answer should be compact. -7.04. In the year 1997, what is the difference between the Pupil-teacher ratio(headcount basis) in Bulgaria and Pupil-teacher ratio(headcount basis) in Cyprus?
Your answer should be very brief. 1.29. In the year 1997, what is the difference between the Pupil-teacher ratio(headcount basis) in Bulgaria and Pupil-teacher ratio(headcount basis) in Tajikistan?
Offer a very short reply. -6.1. In the year 1997, what is the difference between the Pupil-teacher ratio(headcount basis) of China and Pupil-teacher ratio(headcount basis) of Cyprus?
Ensure brevity in your answer.  8.32. In the year 1997, what is the difference between the Pupil-teacher ratio(headcount basis) of China and Pupil-teacher ratio(headcount basis) of Tajikistan?
Give a very brief answer. 0.94. In the year 1997, what is the difference between the Pupil-teacher ratio(headcount basis) in Cyprus and Pupil-teacher ratio(headcount basis) in Tajikistan?
Your answer should be very brief. -7.39. In the year 2001, what is the difference between the Pupil-teacher ratio(headcount basis) in Bulgaria and Pupil-teacher ratio(headcount basis) in China?
Make the answer very short. -4.51. In the year 2001, what is the difference between the Pupil-teacher ratio(headcount basis) of Bulgaria and Pupil-teacher ratio(headcount basis) of Cyprus?
Keep it short and to the point. 0.5. In the year 2001, what is the difference between the Pupil-teacher ratio(headcount basis) in Bulgaria and Pupil-teacher ratio(headcount basis) in Tajikistan?
Give a very brief answer. -4.1. In the year 2001, what is the difference between the Pupil-teacher ratio(headcount basis) of China and Pupil-teacher ratio(headcount basis) of Cyprus?
Keep it short and to the point. 5.01. In the year 2001, what is the difference between the Pupil-teacher ratio(headcount basis) in China and Pupil-teacher ratio(headcount basis) in Tajikistan?
Give a very brief answer. 0.42. In the year 2001, what is the difference between the Pupil-teacher ratio(headcount basis) of Cyprus and Pupil-teacher ratio(headcount basis) of Tajikistan?
Your answer should be compact. -4.59. In the year 2003, what is the difference between the Pupil-teacher ratio(headcount basis) of Bulgaria and Pupil-teacher ratio(headcount basis) of China?
Keep it short and to the point. -3.92. In the year 2003, what is the difference between the Pupil-teacher ratio(headcount basis) in Bulgaria and Pupil-teacher ratio(headcount basis) in Cyprus?
Ensure brevity in your answer.  -1.81. In the year 2003, what is the difference between the Pupil-teacher ratio(headcount basis) of Bulgaria and Pupil-teacher ratio(headcount basis) of Tajikistan?
Your answer should be compact. -5.23. In the year 2003, what is the difference between the Pupil-teacher ratio(headcount basis) in China and Pupil-teacher ratio(headcount basis) in Cyprus?
Keep it short and to the point. 2.11. In the year 2003, what is the difference between the Pupil-teacher ratio(headcount basis) of China and Pupil-teacher ratio(headcount basis) of Tajikistan?
Make the answer very short. -1.31. In the year 2003, what is the difference between the Pupil-teacher ratio(headcount basis) in Cyprus and Pupil-teacher ratio(headcount basis) in Tajikistan?
Ensure brevity in your answer.  -3.42. In the year 2006, what is the difference between the Pupil-teacher ratio(headcount basis) in Bulgaria and Pupil-teacher ratio(headcount basis) in China?
Offer a very short reply. -2.54. In the year 2006, what is the difference between the Pupil-teacher ratio(headcount basis) in Bulgaria and Pupil-teacher ratio(headcount basis) in Cyprus?
Your answer should be very brief. -0.75. In the year 2006, what is the difference between the Pupil-teacher ratio(headcount basis) of Bulgaria and Pupil-teacher ratio(headcount basis) of Tajikistan?
Your response must be concise. -6.47. In the year 2006, what is the difference between the Pupil-teacher ratio(headcount basis) in China and Pupil-teacher ratio(headcount basis) in Cyprus?
Give a very brief answer. 1.79. In the year 2006, what is the difference between the Pupil-teacher ratio(headcount basis) in China and Pupil-teacher ratio(headcount basis) in Tajikistan?
Provide a short and direct response. -3.93. In the year 2006, what is the difference between the Pupil-teacher ratio(headcount basis) in Cyprus and Pupil-teacher ratio(headcount basis) in Tajikistan?
Give a very brief answer. -5.72. In the year 2007, what is the difference between the Pupil-teacher ratio(headcount basis) in Bulgaria and Pupil-teacher ratio(headcount basis) in China?
Give a very brief answer. -1.74. In the year 2007, what is the difference between the Pupil-teacher ratio(headcount basis) of Bulgaria and Pupil-teacher ratio(headcount basis) of Cyprus?
Give a very brief answer. 0.31. In the year 2007, what is the difference between the Pupil-teacher ratio(headcount basis) of Bulgaria and Pupil-teacher ratio(headcount basis) of Tajikistan?
Provide a succinct answer. -5.67. In the year 2007, what is the difference between the Pupil-teacher ratio(headcount basis) of China and Pupil-teacher ratio(headcount basis) of Cyprus?
Give a very brief answer. 2.05. In the year 2007, what is the difference between the Pupil-teacher ratio(headcount basis) in China and Pupil-teacher ratio(headcount basis) in Tajikistan?
Make the answer very short. -3.93. In the year 2007, what is the difference between the Pupil-teacher ratio(headcount basis) of Cyprus and Pupil-teacher ratio(headcount basis) of Tajikistan?
Make the answer very short. -5.98. In the year 2008, what is the difference between the Pupil-teacher ratio(headcount basis) of Bulgaria and Pupil-teacher ratio(headcount basis) of China?
Give a very brief answer. -1.48. In the year 2008, what is the difference between the Pupil-teacher ratio(headcount basis) in Bulgaria and Pupil-teacher ratio(headcount basis) in Cyprus?
Offer a very short reply. 1.32. In the year 2008, what is the difference between the Pupil-teacher ratio(headcount basis) in Bulgaria and Pupil-teacher ratio(headcount basis) in Tajikistan?
Provide a succinct answer. -6.6. In the year 2008, what is the difference between the Pupil-teacher ratio(headcount basis) in China and Pupil-teacher ratio(headcount basis) in Cyprus?
Your response must be concise. 2.8. In the year 2008, what is the difference between the Pupil-teacher ratio(headcount basis) in China and Pupil-teacher ratio(headcount basis) in Tajikistan?
Make the answer very short. -5.12. In the year 2008, what is the difference between the Pupil-teacher ratio(headcount basis) of Cyprus and Pupil-teacher ratio(headcount basis) of Tajikistan?
Keep it short and to the point. -7.92. What is the ratio of the Pupil-teacher ratio(headcount basis) of China in 1996 to that in 1997?
Keep it short and to the point. 0.98. What is the ratio of the Pupil-teacher ratio(headcount basis) of Cyprus in 1996 to that in 1997?
Provide a succinct answer. 1.22. What is the ratio of the Pupil-teacher ratio(headcount basis) of Tajikistan in 1996 to that in 1997?
Offer a very short reply. 0.99. What is the ratio of the Pupil-teacher ratio(headcount basis) of Bulgaria in 1996 to that in 2001?
Your answer should be compact. 0.96. What is the ratio of the Pupil-teacher ratio(headcount basis) in China in 1996 to that in 2001?
Your response must be concise. 1.05. What is the ratio of the Pupil-teacher ratio(headcount basis) of Cyprus in 1996 to that in 2001?
Make the answer very short. 1.09. What is the ratio of the Pupil-teacher ratio(headcount basis) in Tajikistan in 1996 to that in 2001?
Ensure brevity in your answer.  1.03. What is the ratio of the Pupil-teacher ratio(headcount basis) of Bulgaria in 1996 to that in 2003?
Provide a succinct answer. 0.99. What is the ratio of the Pupil-teacher ratio(headcount basis) in China in 1996 to that in 2003?
Provide a short and direct response. 1.11. What is the ratio of the Pupil-teacher ratio(headcount basis) of Cyprus in 1996 to that in 2003?
Offer a terse response. 0.99. What is the ratio of the Pupil-teacher ratio(headcount basis) of Tajikistan in 1996 to that in 2003?
Your answer should be compact. 1.01. What is the ratio of the Pupil-teacher ratio(headcount basis) in Bulgaria in 1996 to that in 2006?
Your answer should be very brief. 1.08. What is the ratio of the Pupil-teacher ratio(headcount basis) of China in 1996 to that in 2006?
Provide a short and direct response. 1.28. What is the ratio of the Pupil-teacher ratio(headcount basis) in Cyprus in 1996 to that in 2006?
Offer a very short reply. 1.14. What is the ratio of the Pupil-teacher ratio(headcount basis) of Tajikistan in 1996 to that in 2006?
Ensure brevity in your answer.  1.01. What is the ratio of the Pupil-teacher ratio(headcount basis) of Bulgaria in 1996 to that in 2007?
Provide a short and direct response. 1.07. What is the ratio of the Pupil-teacher ratio(headcount basis) in China in 1996 to that in 2007?
Your answer should be very brief. 1.32. What is the ratio of the Pupil-teacher ratio(headcount basis) in Cyprus in 1996 to that in 2007?
Your answer should be compact. 1.2. What is the ratio of the Pupil-teacher ratio(headcount basis) in Tajikistan in 1996 to that in 2007?
Provide a short and direct response. 1.04. What is the ratio of the Pupil-teacher ratio(headcount basis) of Bulgaria in 1996 to that in 2008?
Your response must be concise. 1.06. What is the ratio of the Pupil-teacher ratio(headcount basis) in China in 1996 to that in 2008?
Your answer should be very brief. 1.33. What is the ratio of the Pupil-teacher ratio(headcount basis) of Cyprus in 1996 to that in 2008?
Offer a terse response. 1.27. What is the ratio of the Pupil-teacher ratio(headcount basis) of Tajikistan in 1996 to that in 2008?
Give a very brief answer. 0.99. What is the ratio of the Pupil-teacher ratio(headcount basis) of Bulgaria in 1997 to that in 2001?
Provide a short and direct response. 0.94. What is the ratio of the Pupil-teacher ratio(headcount basis) in China in 1997 to that in 2001?
Give a very brief answer. 1.07. What is the ratio of the Pupil-teacher ratio(headcount basis) in Cyprus in 1997 to that in 2001?
Your answer should be compact. 0.9. What is the ratio of the Pupil-teacher ratio(headcount basis) of Tajikistan in 1997 to that in 2001?
Your answer should be compact. 1.05. What is the ratio of the Pupil-teacher ratio(headcount basis) in Bulgaria in 1997 to that in 2003?
Keep it short and to the point. 0.97. What is the ratio of the Pupil-teacher ratio(headcount basis) in China in 1997 to that in 2003?
Your answer should be very brief. 1.13. What is the ratio of the Pupil-teacher ratio(headcount basis) of Cyprus in 1997 to that in 2003?
Your answer should be compact. 0.81. What is the ratio of the Pupil-teacher ratio(headcount basis) of Tajikistan in 1997 to that in 2003?
Give a very brief answer. 1.02. What is the ratio of the Pupil-teacher ratio(headcount basis) in Bulgaria in 1997 to that in 2006?
Offer a terse response. 1.06. What is the ratio of the Pupil-teacher ratio(headcount basis) in China in 1997 to that in 2006?
Ensure brevity in your answer.  1.3. What is the ratio of the Pupil-teacher ratio(headcount basis) of Cyprus in 1997 to that in 2006?
Your response must be concise. 0.94. What is the ratio of the Pupil-teacher ratio(headcount basis) in Tajikistan in 1997 to that in 2006?
Your answer should be compact. 1.03. What is the ratio of the Pupil-teacher ratio(headcount basis) in Bulgaria in 1997 to that in 2007?
Provide a short and direct response. 1.05. What is the ratio of the Pupil-teacher ratio(headcount basis) of China in 1997 to that in 2007?
Provide a succinct answer. 1.34. What is the ratio of the Pupil-teacher ratio(headcount basis) in Tajikistan in 1997 to that in 2007?
Offer a very short reply. 1.05. What is the ratio of the Pupil-teacher ratio(headcount basis) of Bulgaria in 1997 to that in 2008?
Make the answer very short. 1.04. What is the ratio of the Pupil-teacher ratio(headcount basis) in China in 1997 to that in 2008?
Ensure brevity in your answer.  1.35. What is the ratio of the Pupil-teacher ratio(headcount basis) of Cyprus in 1997 to that in 2008?
Your answer should be very brief. 1.04. What is the ratio of the Pupil-teacher ratio(headcount basis) in Tajikistan in 1997 to that in 2008?
Provide a succinct answer. 1.01. What is the ratio of the Pupil-teacher ratio(headcount basis) in Bulgaria in 2001 to that in 2003?
Provide a short and direct response. 1.03. What is the ratio of the Pupil-teacher ratio(headcount basis) of China in 2001 to that in 2003?
Provide a succinct answer. 1.05. What is the ratio of the Pupil-teacher ratio(headcount basis) in Cyprus in 2001 to that in 2003?
Offer a very short reply. 0.91. What is the ratio of the Pupil-teacher ratio(headcount basis) of Tajikistan in 2001 to that in 2003?
Keep it short and to the point. 0.97. What is the ratio of the Pupil-teacher ratio(headcount basis) in Bulgaria in 2001 to that in 2006?
Offer a terse response. 1.13. What is the ratio of the Pupil-teacher ratio(headcount basis) in China in 2001 to that in 2006?
Your answer should be compact. 1.22. What is the ratio of the Pupil-teacher ratio(headcount basis) of Cyprus in 2001 to that in 2006?
Provide a short and direct response. 1.04. What is the ratio of the Pupil-teacher ratio(headcount basis) in Tajikistan in 2001 to that in 2006?
Your response must be concise. 0.98. What is the ratio of the Pupil-teacher ratio(headcount basis) of Bulgaria in 2001 to that in 2007?
Provide a short and direct response. 1.11. What is the ratio of the Pupil-teacher ratio(headcount basis) in China in 2001 to that in 2007?
Your response must be concise. 1.26. What is the ratio of the Pupil-teacher ratio(headcount basis) in Cyprus in 2001 to that in 2007?
Give a very brief answer. 1.1. What is the ratio of the Pupil-teacher ratio(headcount basis) in Tajikistan in 2001 to that in 2007?
Give a very brief answer. 1.01. What is the ratio of the Pupil-teacher ratio(headcount basis) of Bulgaria in 2001 to that in 2008?
Provide a succinct answer. 1.1. What is the ratio of the Pupil-teacher ratio(headcount basis) of China in 2001 to that in 2008?
Your answer should be very brief. 1.26. What is the ratio of the Pupil-teacher ratio(headcount basis) of Cyprus in 2001 to that in 2008?
Your answer should be very brief. 1.17. What is the ratio of the Pupil-teacher ratio(headcount basis) of Tajikistan in 2001 to that in 2008?
Offer a terse response. 0.96. What is the ratio of the Pupil-teacher ratio(headcount basis) in Bulgaria in 2003 to that in 2006?
Provide a succinct answer. 1.09. What is the ratio of the Pupil-teacher ratio(headcount basis) in China in 2003 to that in 2006?
Make the answer very short. 1.15. What is the ratio of the Pupil-teacher ratio(headcount basis) in Cyprus in 2003 to that in 2006?
Provide a short and direct response. 1.15. What is the ratio of the Pupil-teacher ratio(headcount basis) of Tajikistan in 2003 to that in 2006?
Give a very brief answer. 1.01. What is the ratio of the Pupil-teacher ratio(headcount basis) in Bulgaria in 2003 to that in 2007?
Ensure brevity in your answer.  1.07. What is the ratio of the Pupil-teacher ratio(headcount basis) in China in 2003 to that in 2007?
Your response must be concise. 1.19. What is the ratio of the Pupil-teacher ratio(headcount basis) of Cyprus in 2003 to that in 2007?
Make the answer very short. 1.21. What is the ratio of the Pupil-teacher ratio(headcount basis) in Tajikistan in 2003 to that in 2007?
Provide a succinct answer. 1.03. What is the ratio of the Pupil-teacher ratio(headcount basis) of Bulgaria in 2003 to that in 2008?
Offer a very short reply. 1.07. What is the ratio of the Pupil-teacher ratio(headcount basis) in China in 2003 to that in 2008?
Offer a terse response. 1.2. What is the ratio of the Pupil-teacher ratio(headcount basis) in Cyprus in 2003 to that in 2008?
Keep it short and to the point. 1.28. What is the ratio of the Pupil-teacher ratio(headcount basis) in Tajikistan in 2003 to that in 2008?
Your response must be concise. 0.99. What is the ratio of the Pupil-teacher ratio(headcount basis) in Bulgaria in 2006 to that in 2007?
Offer a very short reply. 0.99. What is the ratio of the Pupil-teacher ratio(headcount basis) in China in 2006 to that in 2007?
Make the answer very short. 1.03. What is the ratio of the Pupil-teacher ratio(headcount basis) of Cyprus in 2006 to that in 2007?
Your answer should be very brief. 1.05. What is the ratio of the Pupil-teacher ratio(headcount basis) of Tajikistan in 2006 to that in 2007?
Provide a succinct answer. 1.03. What is the ratio of the Pupil-teacher ratio(headcount basis) in Bulgaria in 2006 to that in 2008?
Provide a short and direct response. 0.98. What is the ratio of the Pupil-teacher ratio(headcount basis) of China in 2006 to that in 2008?
Give a very brief answer. 1.04. What is the ratio of the Pupil-teacher ratio(headcount basis) in Cyprus in 2006 to that in 2008?
Your answer should be very brief. 1.12. What is the ratio of the Pupil-teacher ratio(headcount basis) of Tajikistan in 2006 to that in 2008?
Your answer should be very brief. 0.98. What is the ratio of the Pupil-teacher ratio(headcount basis) of China in 2007 to that in 2008?
Provide a succinct answer. 1.01. What is the ratio of the Pupil-teacher ratio(headcount basis) of Cyprus in 2007 to that in 2008?
Provide a short and direct response. 1.06. What is the ratio of the Pupil-teacher ratio(headcount basis) of Tajikistan in 2007 to that in 2008?
Offer a very short reply. 0.95. What is the difference between the highest and the second highest Pupil-teacher ratio(headcount basis) of Bulgaria?
Offer a terse response. 0.56. What is the difference between the highest and the second highest Pupil-teacher ratio(headcount basis) of China?
Give a very brief answer. 0.44. What is the difference between the highest and the second highest Pupil-teacher ratio(headcount basis) in Cyprus?
Provide a short and direct response. 0.21. What is the difference between the highest and the second highest Pupil-teacher ratio(headcount basis) of Tajikistan?
Ensure brevity in your answer.  0.12. What is the difference between the highest and the lowest Pupil-teacher ratio(headcount basis) in Bulgaria?
Provide a short and direct response. 1.98. What is the difference between the highest and the lowest Pupil-teacher ratio(headcount basis) in China?
Your response must be concise. 6.18. What is the difference between the highest and the lowest Pupil-teacher ratio(headcount basis) of Cyprus?
Keep it short and to the point. 4.19. What is the difference between the highest and the lowest Pupil-teacher ratio(headcount basis) in Tajikistan?
Offer a very short reply. 1.19. 